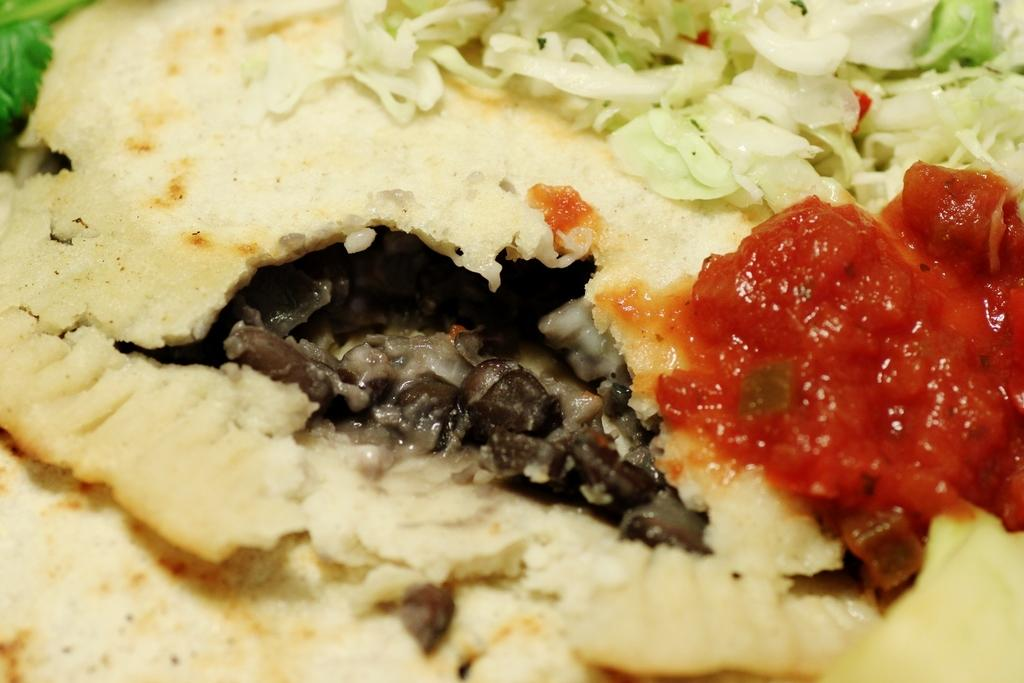What type of food can be seen in the image? The image contains food with cream, green, grey, and red colors. Can you describe the colors of the food in the image? The food has cream, green, grey, and red colors. How many cars are parked inside the cave in the image? There are no cars or caves present in the image; it features food with various colors. 